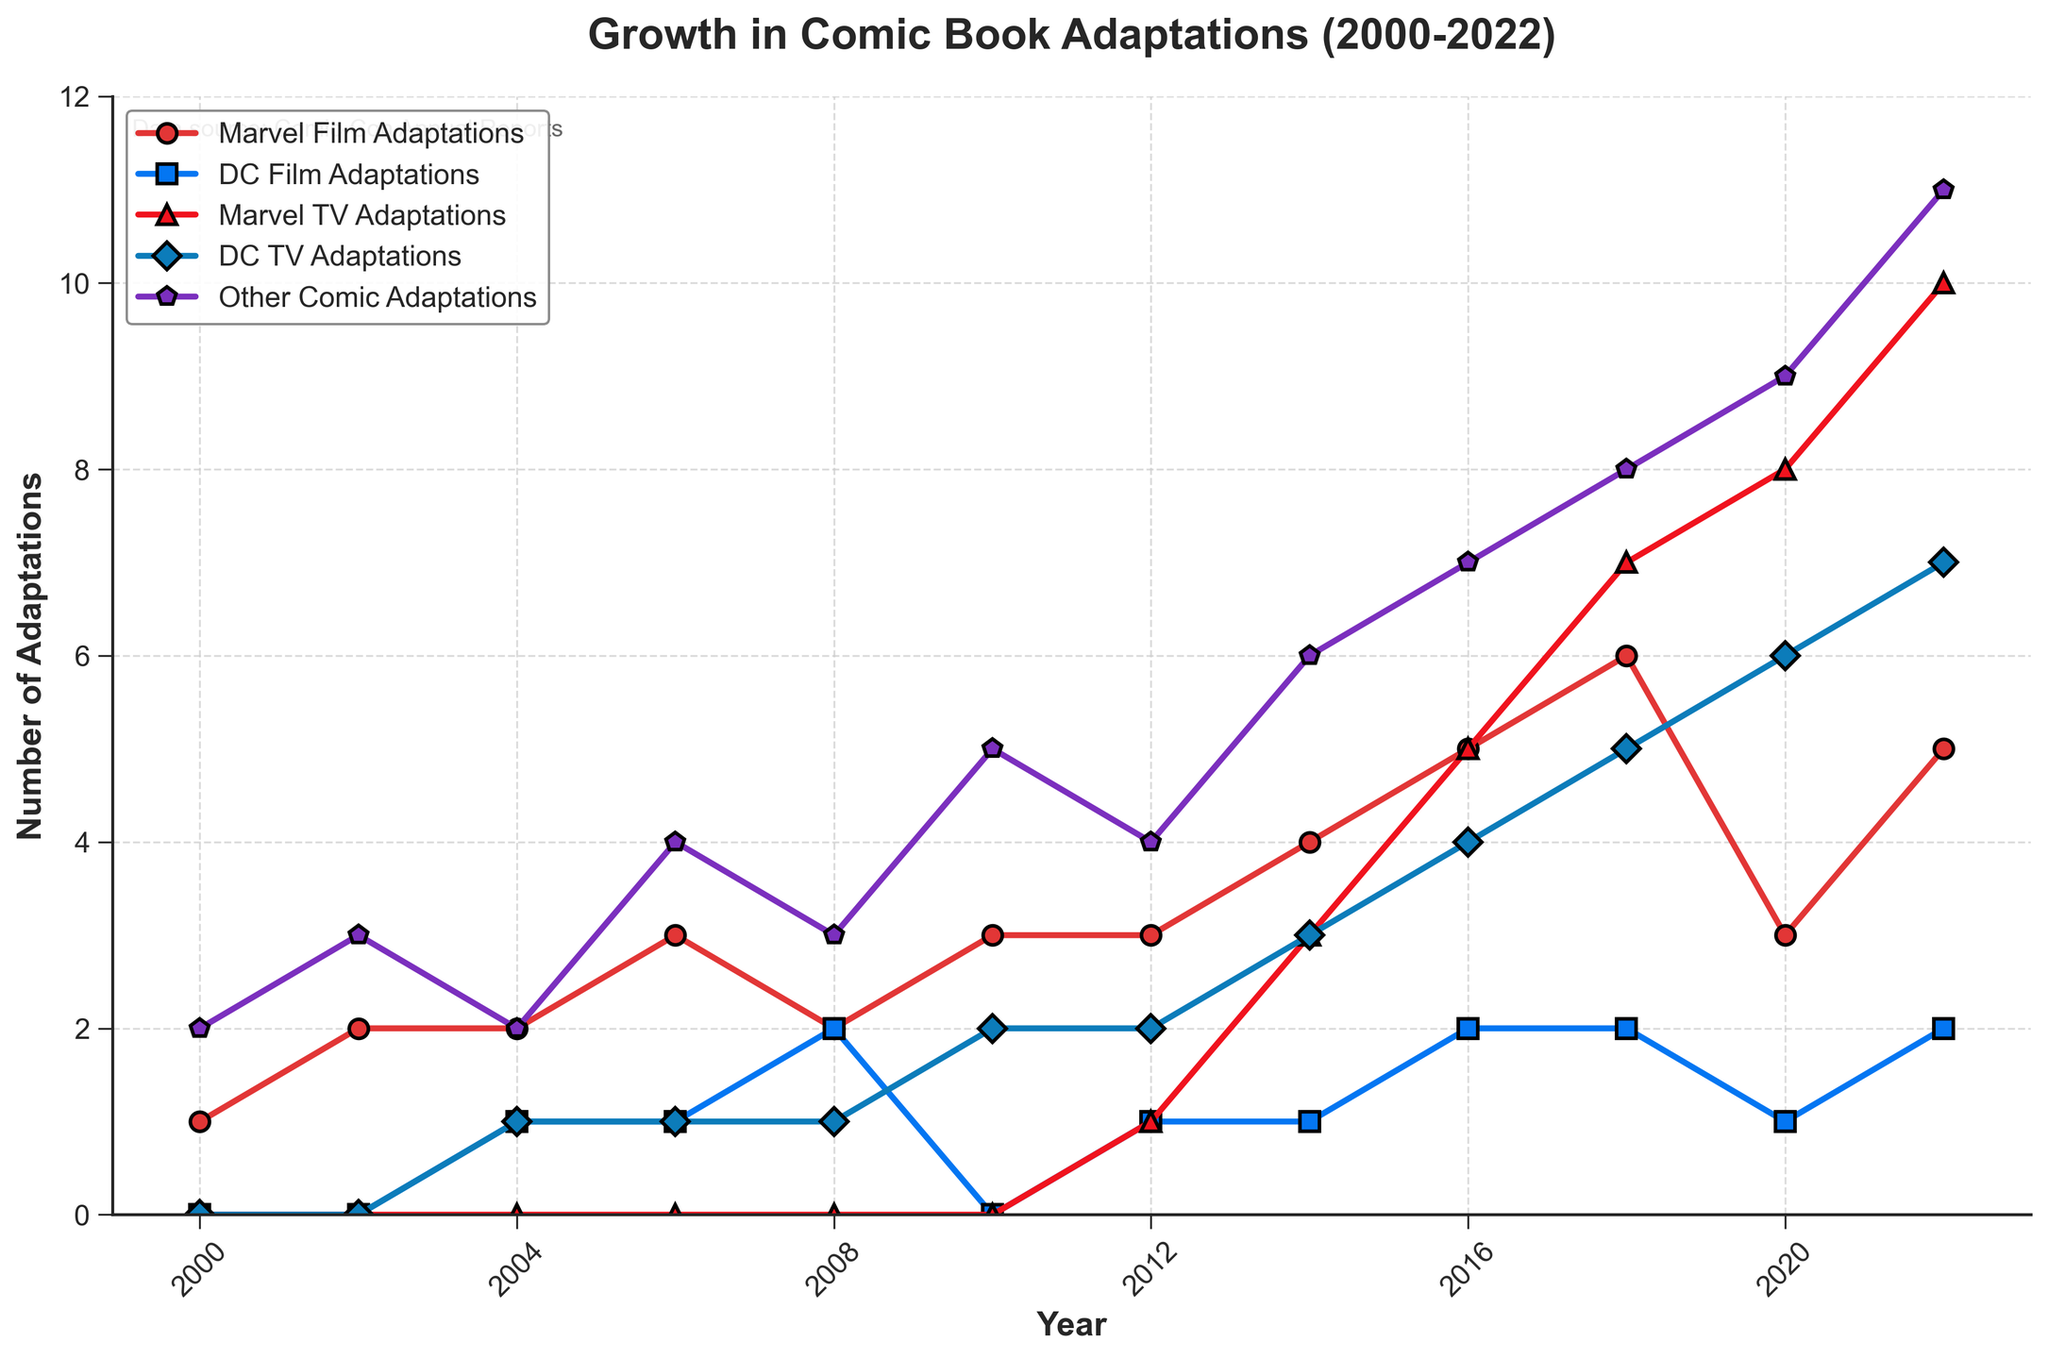Which category had the highest number of adaptations in 2022? Looking at the end of the chart for 2022, the tall bar colored in purple (representing Other Comic Adaptations) reaches the highest value compared to the other categories.
Answer: Other Comic Adaptations How many Marvel TV Adaptations and DC TV Adaptations were there in total in 2020? In 2020, Marvel TV Adaptations had a value of 8 and DC TV Adaptations had a value of 6. Adding these together gives us 8 + 6.
Answer: 14 Which years had more Marvel Film Adaptations than DC Film Adaptations? Checking each year's values for Marvel and DC Film Adaptations, it's clear that 2000, 2002, 2004, 2006, 2010, 2012, 2014, and 2018 have higher Marvel Film Adaptations values compared to DC Film Adaptations.
Answer: 2000, 2002, 2004, 2006, 2010, 2012, 2014, 2018 When did DC TV Adaptations first appear? Observing the chart, the first non-zero value (1) for DC TV Adaptations appears in 2004.
Answer: 2004 By how much did the number of Other Comic Adaptations grow from 2000 to 2022? In 2000, Other Comic Adaptations had a value of 2, and in 2022, it had a value of 11. The difference between these two values is 11 - 2.
Answer: 9 In which year did Marvel Film Adaptations and DC Film Adaptations both have the same number? Both categories have equal values of 2 in the year 2008.
Answer: 2008 Compare the trend in Marvel TV Adaptations to DC TV Adaptations over the years. Marvel TV Adaptations started appearing in 2012 and consistently grew, reaching 10 in 2022, whereas DC TV Adaptations also started in 2004 but grew at a slower rate to 7 in 2022. Thus, Marvel TV Adaptations saw more rapid growth.
Answer: Marvel TV Adaptations had a more rapid growth What is the sum of all DC Film Adaptations from 2000 to 2022? Adding up the values from the DC Film Adaptations column: 0 + 0 + 1 + 1 + 2 + 0 + 1 + 1 + 2 + 2 + 1 + 2 gives a total of 13.
Answer: 13 Which category showed a consistent upward trend without any drop across the years? Checking each category, Marvel TV Adaptations show a consistent upward trend starting from 2012 without any declines.
Answer: Marvel TV Adaptations 